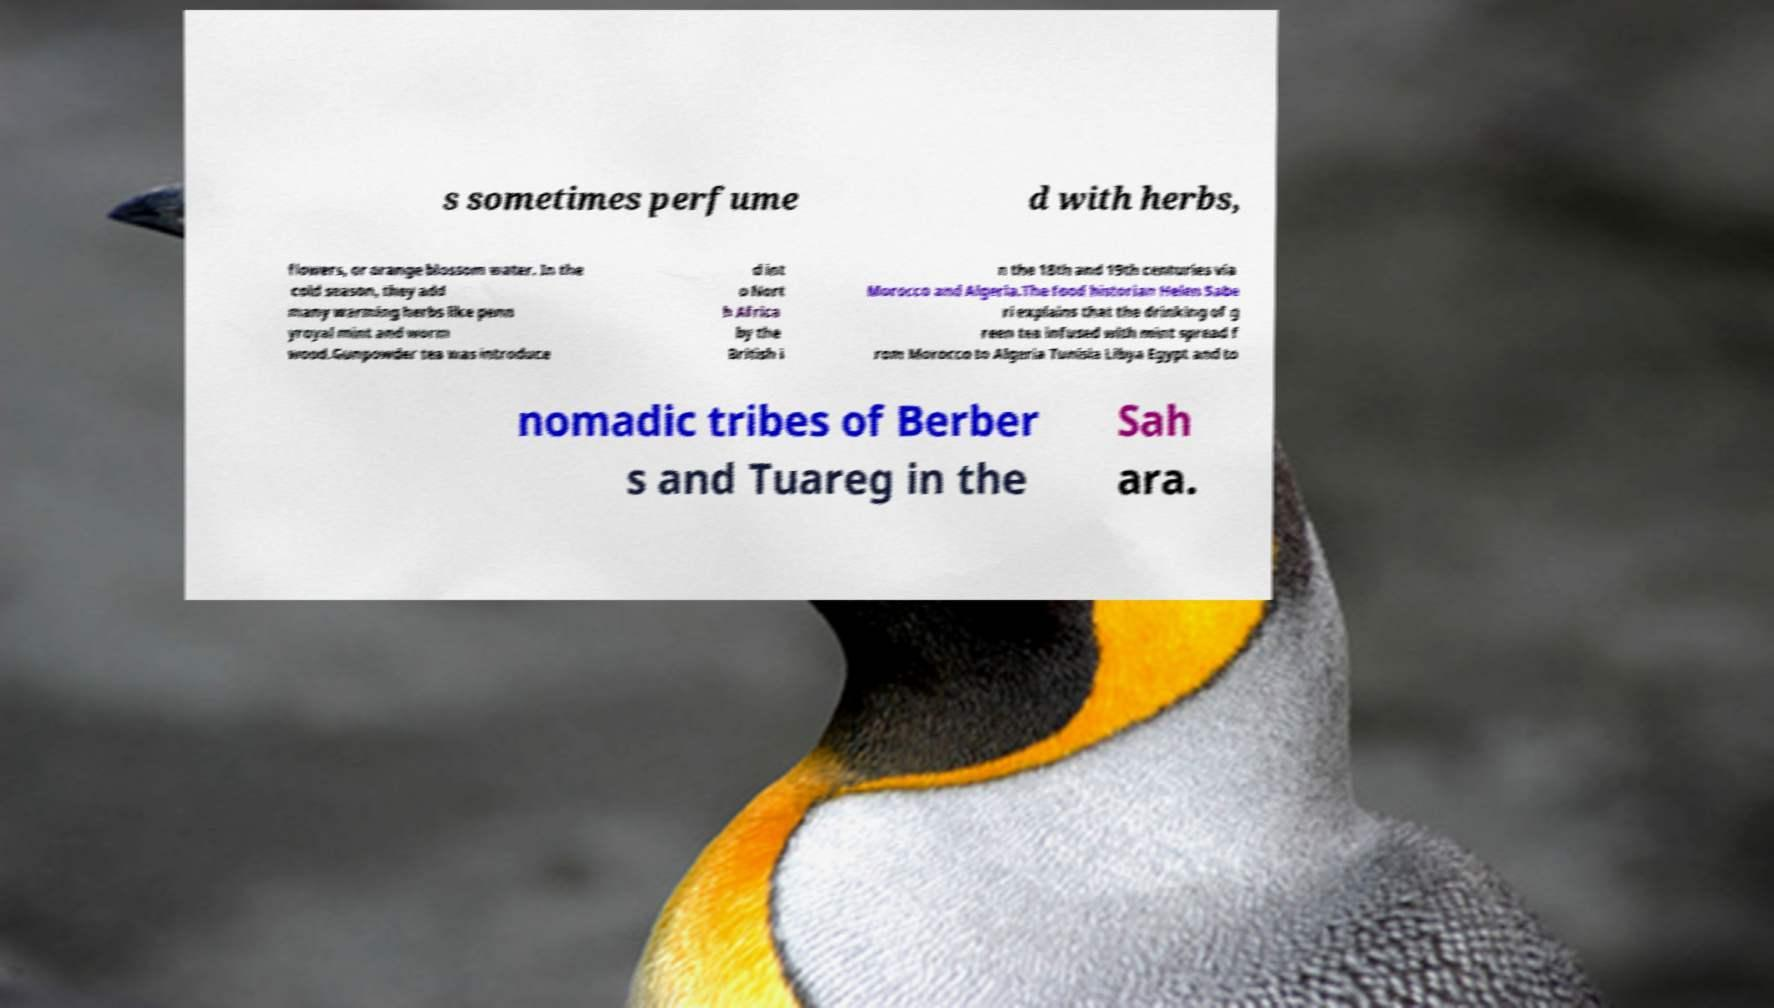Please identify and transcribe the text found in this image. s sometimes perfume d with herbs, flowers, or orange blossom water. In the cold season, they add many warming herbs like penn yroyal mint and worm wood.Gunpowder tea was introduce d int o Nort h Africa by the British i n the 18th and 19th centuries via Morocco and Algeria.The food historian Helen Sabe ri explains that the drinking of g reen tea infused with mint spread f rom Morocco to Algeria Tunisia Libya Egypt and to nomadic tribes of Berber s and Tuareg in the Sah ara. 